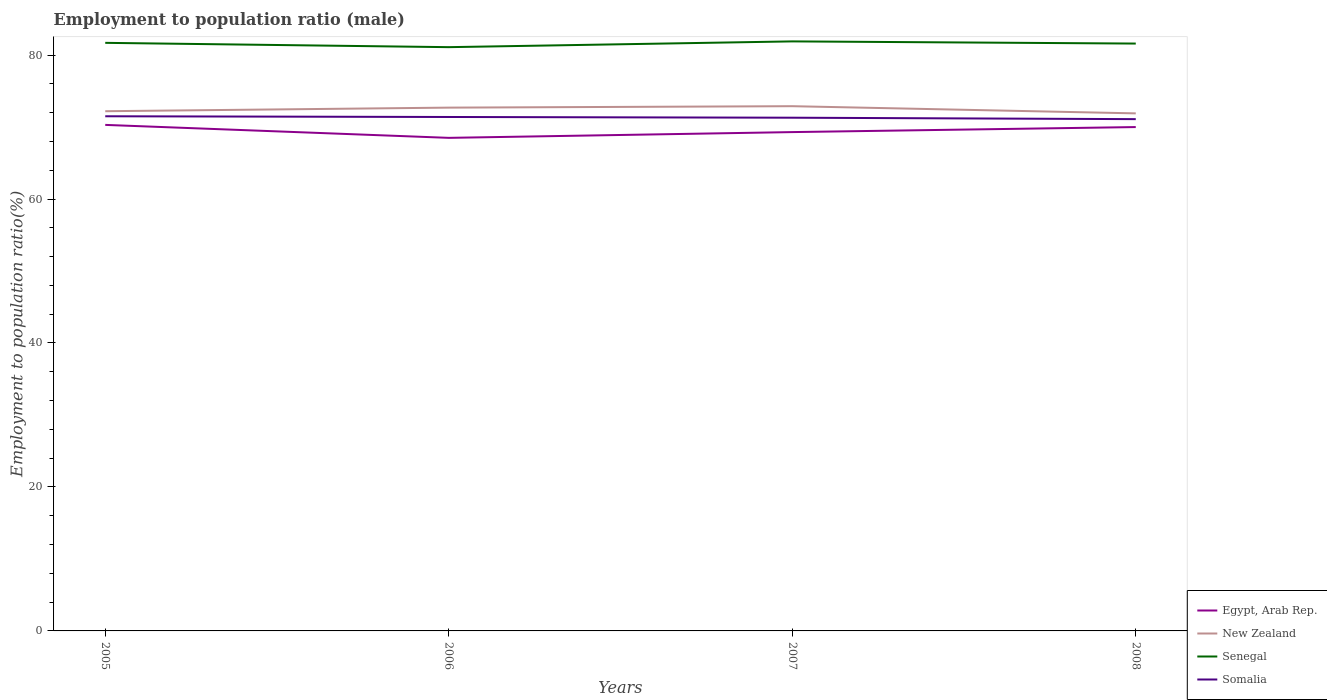How many different coloured lines are there?
Your answer should be very brief. 4. Is the number of lines equal to the number of legend labels?
Provide a succinct answer. Yes. Across all years, what is the maximum employment to population ratio in Somalia?
Your answer should be very brief. 71.1. In which year was the employment to population ratio in Senegal maximum?
Provide a succinct answer. 2006. What is the total employment to population ratio in Somalia in the graph?
Give a very brief answer. 0.3. What is the difference between the highest and the second highest employment to population ratio in New Zealand?
Your answer should be compact. 1. What is the difference between the highest and the lowest employment to population ratio in Egypt, Arab Rep.?
Your response must be concise. 2. Is the employment to population ratio in New Zealand strictly greater than the employment to population ratio in Somalia over the years?
Offer a terse response. No. How many years are there in the graph?
Your response must be concise. 4. Are the values on the major ticks of Y-axis written in scientific E-notation?
Keep it short and to the point. No. Does the graph contain any zero values?
Offer a terse response. No. Does the graph contain grids?
Provide a succinct answer. No. Where does the legend appear in the graph?
Your answer should be very brief. Bottom right. How many legend labels are there?
Provide a short and direct response. 4. How are the legend labels stacked?
Offer a very short reply. Vertical. What is the title of the graph?
Provide a succinct answer. Employment to population ratio (male). What is the Employment to population ratio(%) of Egypt, Arab Rep. in 2005?
Make the answer very short. 70.3. What is the Employment to population ratio(%) of New Zealand in 2005?
Make the answer very short. 72.2. What is the Employment to population ratio(%) in Senegal in 2005?
Give a very brief answer. 81.7. What is the Employment to population ratio(%) in Somalia in 2005?
Make the answer very short. 71.5. What is the Employment to population ratio(%) in Egypt, Arab Rep. in 2006?
Give a very brief answer. 68.5. What is the Employment to population ratio(%) in New Zealand in 2006?
Offer a very short reply. 72.7. What is the Employment to population ratio(%) of Senegal in 2006?
Your answer should be compact. 81.1. What is the Employment to population ratio(%) in Somalia in 2006?
Ensure brevity in your answer.  71.4. What is the Employment to population ratio(%) of Egypt, Arab Rep. in 2007?
Make the answer very short. 69.3. What is the Employment to population ratio(%) in New Zealand in 2007?
Your response must be concise. 72.9. What is the Employment to population ratio(%) of Senegal in 2007?
Give a very brief answer. 81.9. What is the Employment to population ratio(%) of Somalia in 2007?
Your answer should be very brief. 71.3. What is the Employment to population ratio(%) of Egypt, Arab Rep. in 2008?
Your answer should be very brief. 70. What is the Employment to population ratio(%) of New Zealand in 2008?
Give a very brief answer. 71.9. What is the Employment to population ratio(%) in Senegal in 2008?
Give a very brief answer. 81.6. What is the Employment to population ratio(%) in Somalia in 2008?
Make the answer very short. 71.1. Across all years, what is the maximum Employment to population ratio(%) in Egypt, Arab Rep.?
Keep it short and to the point. 70.3. Across all years, what is the maximum Employment to population ratio(%) of New Zealand?
Provide a short and direct response. 72.9. Across all years, what is the maximum Employment to population ratio(%) of Senegal?
Make the answer very short. 81.9. Across all years, what is the maximum Employment to population ratio(%) in Somalia?
Your response must be concise. 71.5. Across all years, what is the minimum Employment to population ratio(%) in Egypt, Arab Rep.?
Your response must be concise. 68.5. Across all years, what is the minimum Employment to population ratio(%) of New Zealand?
Your response must be concise. 71.9. Across all years, what is the minimum Employment to population ratio(%) in Senegal?
Offer a terse response. 81.1. Across all years, what is the minimum Employment to population ratio(%) of Somalia?
Give a very brief answer. 71.1. What is the total Employment to population ratio(%) in Egypt, Arab Rep. in the graph?
Ensure brevity in your answer.  278.1. What is the total Employment to population ratio(%) of New Zealand in the graph?
Your response must be concise. 289.7. What is the total Employment to population ratio(%) of Senegal in the graph?
Offer a terse response. 326.3. What is the total Employment to population ratio(%) in Somalia in the graph?
Your answer should be very brief. 285.3. What is the difference between the Employment to population ratio(%) of Egypt, Arab Rep. in 2005 and that in 2006?
Offer a terse response. 1.8. What is the difference between the Employment to population ratio(%) of New Zealand in 2005 and that in 2006?
Offer a terse response. -0.5. What is the difference between the Employment to population ratio(%) in Senegal in 2005 and that in 2006?
Give a very brief answer. 0.6. What is the difference between the Employment to population ratio(%) of Somalia in 2005 and that in 2007?
Keep it short and to the point. 0.2. What is the difference between the Employment to population ratio(%) of New Zealand in 2005 and that in 2008?
Provide a short and direct response. 0.3. What is the difference between the Employment to population ratio(%) in Senegal in 2005 and that in 2008?
Give a very brief answer. 0.1. What is the difference between the Employment to population ratio(%) in Somalia in 2005 and that in 2008?
Keep it short and to the point. 0.4. What is the difference between the Employment to population ratio(%) of Egypt, Arab Rep. in 2006 and that in 2007?
Make the answer very short. -0.8. What is the difference between the Employment to population ratio(%) in New Zealand in 2006 and that in 2007?
Provide a succinct answer. -0.2. What is the difference between the Employment to population ratio(%) in Senegal in 2006 and that in 2008?
Give a very brief answer. -0.5. What is the difference between the Employment to population ratio(%) in Somalia in 2006 and that in 2008?
Your response must be concise. 0.3. What is the difference between the Employment to population ratio(%) of New Zealand in 2007 and that in 2008?
Make the answer very short. 1. What is the difference between the Employment to population ratio(%) in Egypt, Arab Rep. in 2005 and the Employment to population ratio(%) in Senegal in 2006?
Make the answer very short. -10.8. What is the difference between the Employment to population ratio(%) of Egypt, Arab Rep. in 2005 and the Employment to population ratio(%) of Somalia in 2006?
Your answer should be very brief. -1.1. What is the difference between the Employment to population ratio(%) of New Zealand in 2005 and the Employment to population ratio(%) of Somalia in 2006?
Offer a terse response. 0.8. What is the difference between the Employment to population ratio(%) of Senegal in 2005 and the Employment to population ratio(%) of Somalia in 2006?
Provide a short and direct response. 10.3. What is the difference between the Employment to population ratio(%) in Egypt, Arab Rep. in 2005 and the Employment to population ratio(%) in New Zealand in 2007?
Offer a terse response. -2.6. What is the difference between the Employment to population ratio(%) of Egypt, Arab Rep. in 2005 and the Employment to population ratio(%) of Senegal in 2007?
Your answer should be compact. -11.6. What is the difference between the Employment to population ratio(%) of New Zealand in 2005 and the Employment to population ratio(%) of Senegal in 2007?
Ensure brevity in your answer.  -9.7. What is the difference between the Employment to population ratio(%) in New Zealand in 2005 and the Employment to population ratio(%) in Somalia in 2007?
Provide a succinct answer. 0.9. What is the difference between the Employment to population ratio(%) in Egypt, Arab Rep. in 2005 and the Employment to population ratio(%) in New Zealand in 2008?
Provide a short and direct response. -1.6. What is the difference between the Employment to population ratio(%) in Egypt, Arab Rep. in 2005 and the Employment to population ratio(%) in Senegal in 2008?
Offer a very short reply. -11.3. What is the difference between the Employment to population ratio(%) in Senegal in 2005 and the Employment to population ratio(%) in Somalia in 2008?
Your answer should be very brief. 10.6. What is the difference between the Employment to population ratio(%) in Egypt, Arab Rep. in 2006 and the Employment to population ratio(%) in Senegal in 2007?
Provide a succinct answer. -13.4. What is the difference between the Employment to population ratio(%) in New Zealand in 2006 and the Employment to population ratio(%) in Somalia in 2007?
Give a very brief answer. 1.4. What is the difference between the Employment to population ratio(%) of Egypt, Arab Rep. in 2006 and the Employment to population ratio(%) of New Zealand in 2008?
Your response must be concise. -3.4. What is the difference between the Employment to population ratio(%) of Egypt, Arab Rep. in 2006 and the Employment to population ratio(%) of Somalia in 2008?
Make the answer very short. -2.6. What is the difference between the Employment to population ratio(%) of New Zealand in 2006 and the Employment to population ratio(%) of Senegal in 2008?
Offer a terse response. -8.9. What is the difference between the Employment to population ratio(%) of New Zealand in 2006 and the Employment to population ratio(%) of Somalia in 2008?
Give a very brief answer. 1.6. What is the difference between the Employment to population ratio(%) of Senegal in 2006 and the Employment to population ratio(%) of Somalia in 2008?
Provide a short and direct response. 10. What is the difference between the Employment to population ratio(%) in Egypt, Arab Rep. in 2007 and the Employment to population ratio(%) in New Zealand in 2008?
Ensure brevity in your answer.  -2.6. What is the difference between the Employment to population ratio(%) in Egypt, Arab Rep. in 2007 and the Employment to population ratio(%) in Senegal in 2008?
Your answer should be very brief. -12.3. What is the difference between the Employment to population ratio(%) of New Zealand in 2007 and the Employment to population ratio(%) of Senegal in 2008?
Your answer should be compact. -8.7. What is the average Employment to population ratio(%) of Egypt, Arab Rep. per year?
Keep it short and to the point. 69.53. What is the average Employment to population ratio(%) of New Zealand per year?
Make the answer very short. 72.42. What is the average Employment to population ratio(%) in Senegal per year?
Give a very brief answer. 81.58. What is the average Employment to population ratio(%) in Somalia per year?
Offer a very short reply. 71.33. In the year 2005, what is the difference between the Employment to population ratio(%) of Egypt, Arab Rep. and Employment to population ratio(%) of Somalia?
Offer a terse response. -1.2. In the year 2005, what is the difference between the Employment to population ratio(%) in New Zealand and Employment to population ratio(%) in Senegal?
Make the answer very short. -9.5. In the year 2005, what is the difference between the Employment to population ratio(%) in New Zealand and Employment to population ratio(%) in Somalia?
Keep it short and to the point. 0.7. In the year 2005, what is the difference between the Employment to population ratio(%) in Senegal and Employment to population ratio(%) in Somalia?
Your response must be concise. 10.2. In the year 2006, what is the difference between the Employment to population ratio(%) of Egypt, Arab Rep. and Employment to population ratio(%) of Senegal?
Give a very brief answer. -12.6. In the year 2006, what is the difference between the Employment to population ratio(%) of New Zealand and Employment to population ratio(%) of Senegal?
Offer a terse response. -8.4. In the year 2006, what is the difference between the Employment to population ratio(%) in Senegal and Employment to population ratio(%) in Somalia?
Make the answer very short. 9.7. In the year 2007, what is the difference between the Employment to population ratio(%) in Egypt, Arab Rep. and Employment to population ratio(%) in Senegal?
Provide a succinct answer. -12.6. In the year 2007, what is the difference between the Employment to population ratio(%) of Egypt, Arab Rep. and Employment to population ratio(%) of Somalia?
Provide a short and direct response. -2. In the year 2008, what is the difference between the Employment to population ratio(%) of Egypt, Arab Rep. and Employment to population ratio(%) of New Zealand?
Ensure brevity in your answer.  -1.9. In the year 2008, what is the difference between the Employment to population ratio(%) in New Zealand and Employment to population ratio(%) in Somalia?
Give a very brief answer. 0.8. What is the ratio of the Employment to population ratio(%) in Egypt, Arab Rep. in 2005 to that in 2006?
Give a very brief answer. 1.03. What is the ratio of the Employment to population ratio(%) in New Zealand in 2005 to that in 2006?
Offer a terse response. 0.99. What is the ratio of the Employment to population ratio(%) of Senegal in 2005 to that in 2006?
Keep it short and to the point. 1.01. What is the ratio of the Employment to population ratio(%) in Somalia in 2005 to that in 2006?
Offer a terse response. 1. What is the ratio of the Employment to population ratio(%) in Egypt, Arab Rep. in 2005 to that in 2007?
Offer a very short reply. 1.01. What is the ratio of the Employment to population ratio(%) in New Zealand in 2005 to that in 2007?
Your answer should be compact. 0.99. What is the ratio of the Employment to population ratio(%) in Egypt, Arab Rep. in 2005 to that in 2008?
Make the answer very short. 1. What is the ratio of the Employment to population ratio(%) in Senegal in 2005 to that in 2008?
Keep it short and to the point. 1. What is the ratio of the Employment to population ratio(%) in Somalia in 2005 to that in 2008?
Keep it short and to the point. 1.01. What is the ratio of the Employment to population ratio(%) in Senegal in 2006 to that in 2007?
Offer a terse response. 0.99. What is the ratio of the Employment to population ratio(%) in Somalia in 2006 to that in 2007?
Your answer should be very brief. 1. What is the ratio of the Employment to population ratio(%) in Egypt, Arab Rep. in 2006 to that in 2008?
Provide a succinct answer. 0.98. What is the ratio of the Employment to population ratio(%) of New Zealand in 2006 to that in 2008?
Your answer should be very brief. 1.01. What is the ratio of the Employment to population ratio(%) of New Zealand in 2007 to that in 2008?
Provide a short and direct response. 1.01. What is the ratio of the Employment to population ratio(%) in Somalia in 2007 to that in 2008?
Make the answer very short. 1. What is the difference between the highest and the second highest Employment to population ratio(%) of New Zealand?
Your response must be concise. 0.2. What is the difference between the highest and the lowest Employment to population ratio(%) of Egypt, Arab Rep.?
Keep it short and to the point. 1.8. What is the difference between the highest and the lowest Employment to population ratio(%) of Senegal?
Your answer should be compact. 0.8. 